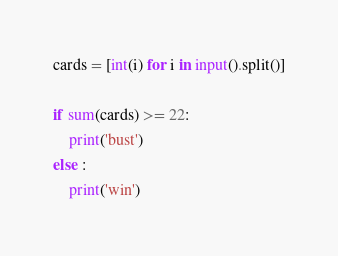<code> <loc_0><loc_0><loc_500><loc_500><_Python_>cards = [int(i) for i in input().split()]

if sum(cards) >= 22:
    print('bust')
else :
    print('win')</code> 